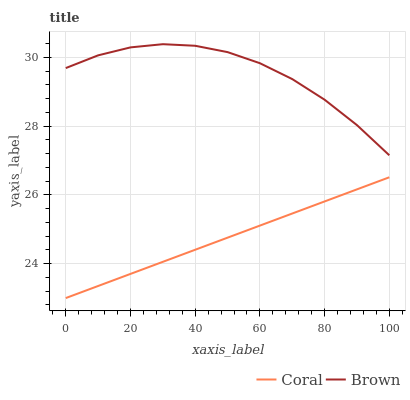Does Coral have the minimum area under the curve?
Answer yes or no. Yes. Does Brown have the maximum area under the curve?
Answer yes or no. Yes. Does Coral have the maximum area under the curve?
Answer yes or no. No. Is Coral the smoothest?
Answer yes or no. Yes. Is Brown the roughest?
Answer yes or no. Yes. Is Coral the roughest?
Answer yes or no. No. Does Coral have the lowest value?
Answer yes or no. Yes. Does Brown have the highest value?
Answer yes or no. Yes. Does Coral have the highest value?
Answer yes or no. No. Is Coral less than Brown?
Answer yes or no. Yes. Is Brown greater than Coral?
Answer yes or no. Yes. Does Coral intersect Brown?
Answer yes or no. No. 